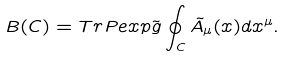<formula> <loc_0><loc_0><loc_500><loc_500>B ( C ) = T r P e x p \tilde { g } \oint _ { C } \tilde { A } _ { \mu } ( x ) d x ^ { \mu } .</formula> 